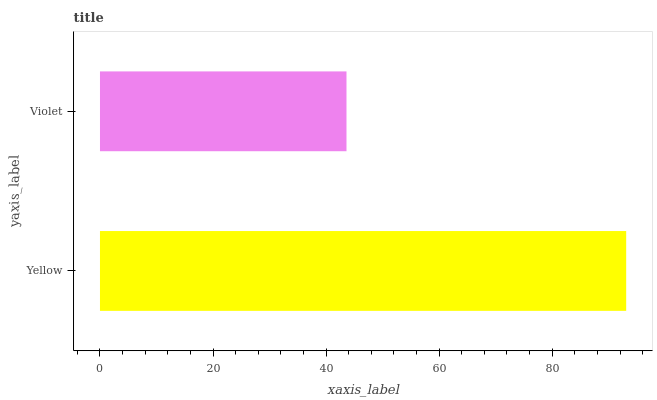Is Violet the minimum?
Answer yes or no. Yes. Is Yellow the maximum?
Answer yes or no. Yes. Is Violet the maximum?
Answer yes or no. No. Is Yellow greater than Violet?
Answer yes or no. Yes. Is Violet less than Yellow?
Answer yes or no. Yes. Is Violet greater than Yellow?
Answer yes or no. No. Is Yellow less than Violet?
Answer yes or no. No. Is Yellow the high median?
Answer yes or no. Yes. Is Violet the low median?
Answer yes or no. Yes. Is Violet the high median?
Answer yes or no. No. Is Yellow the low median?
Answer yes or no. No. 